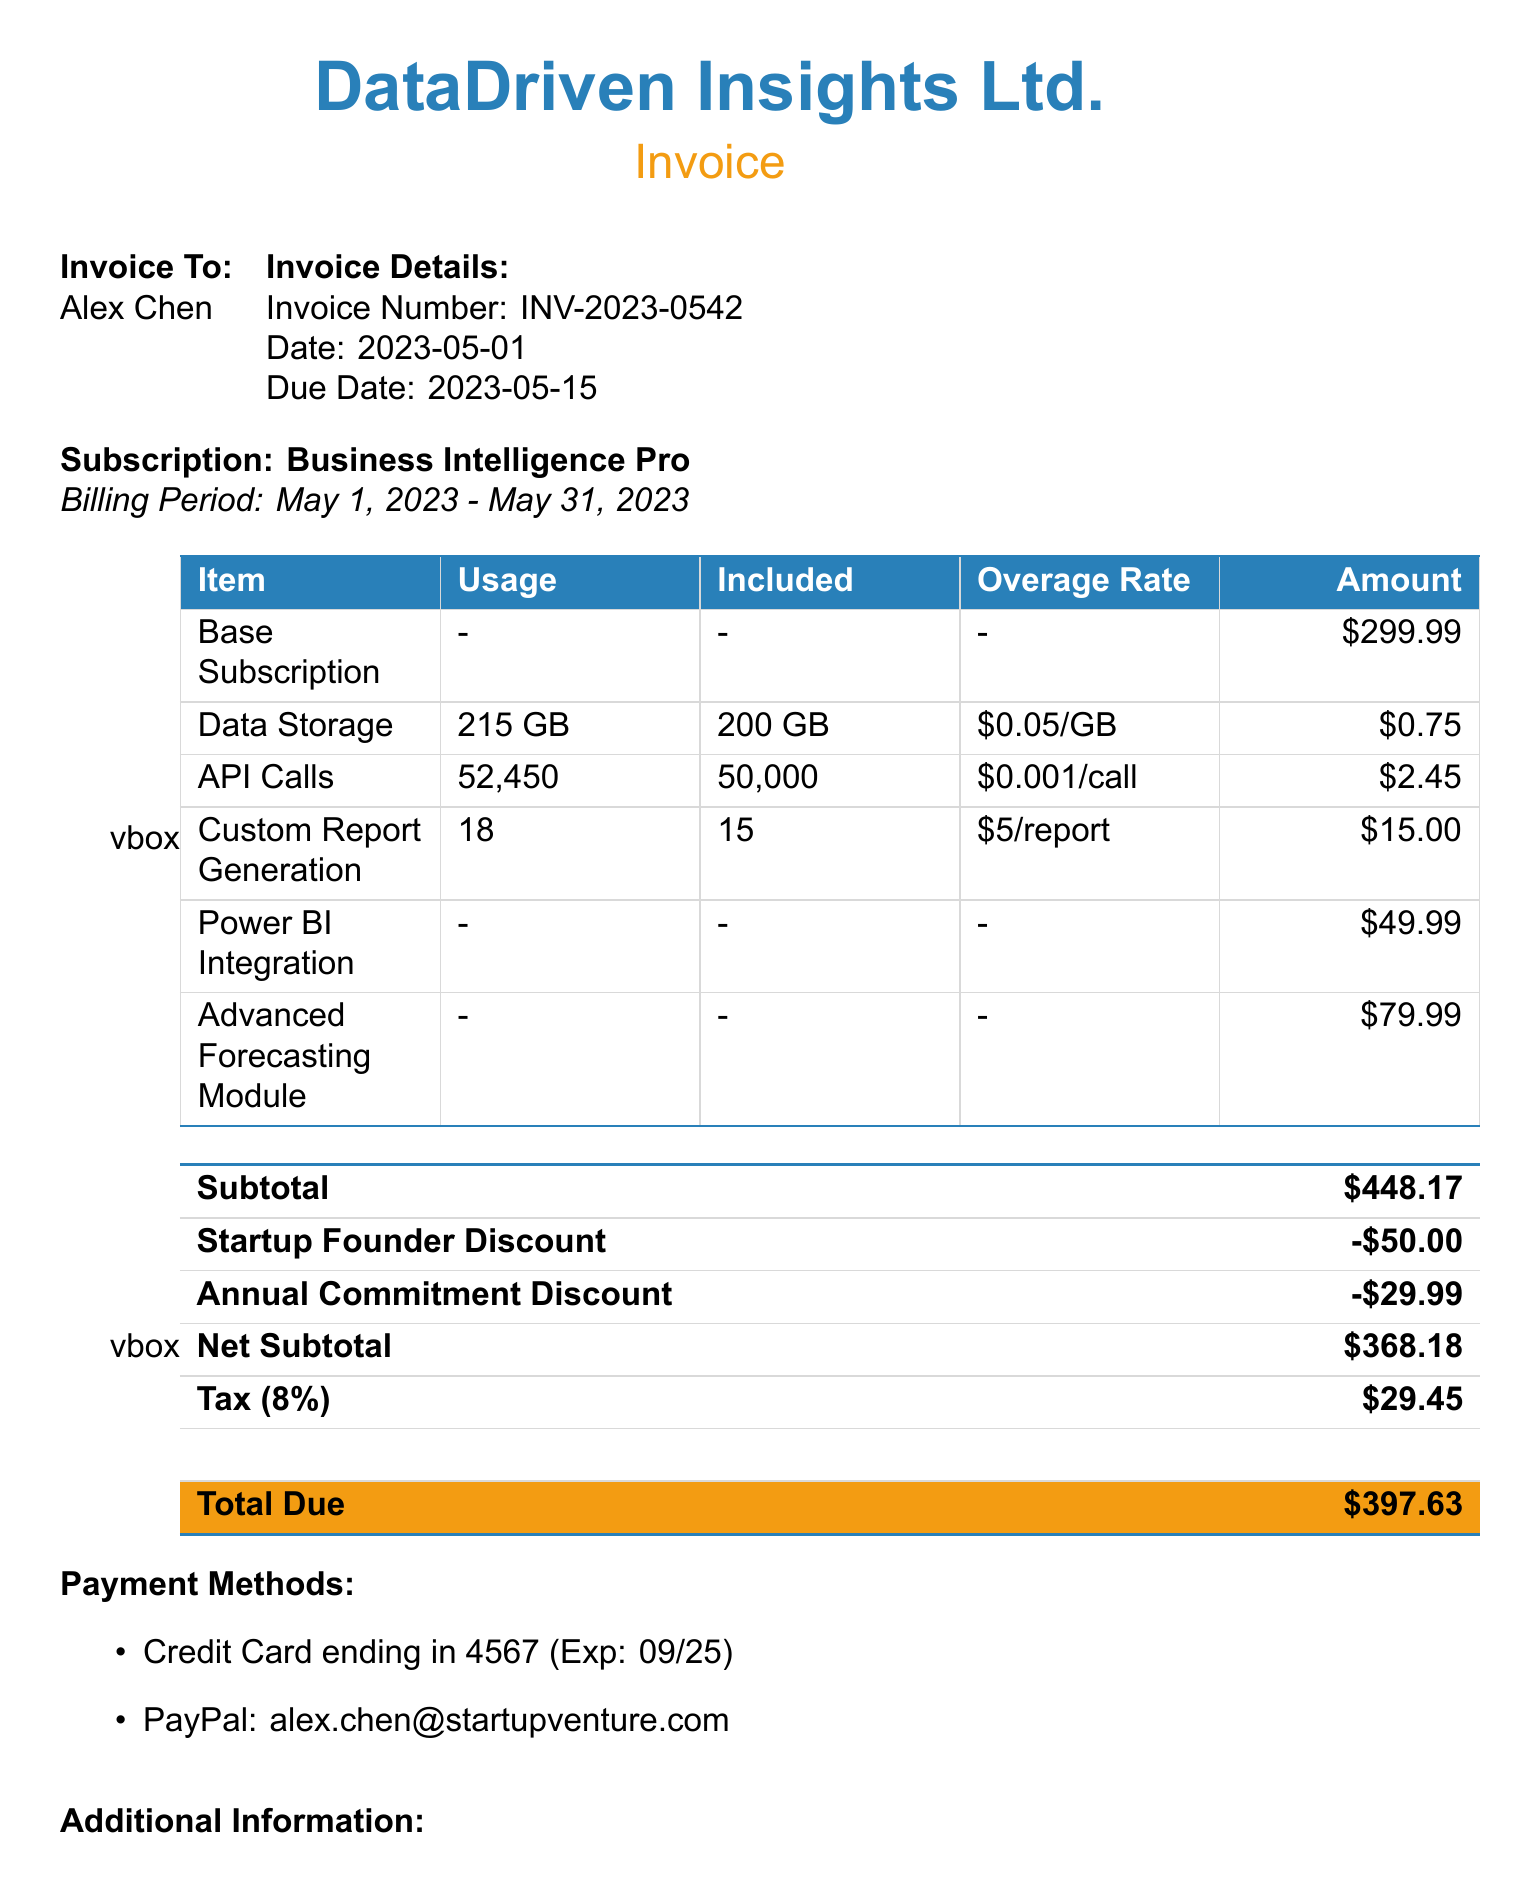What is the customer name? The customer's name is listed in the document as Alex Chen.
Answer: Alex Chen What is the invoice number? The invoice number is specified clearly in the invoice details section.
Answer: INV-2023-0542 What is the billing period for the subscription? The billing period indicates the timeframe for which the service is being billed.
Answer: May 1, 2023 - May 31, 2023 How much is the overage charge for Data Storage? The overage charge for Data Storage is specified next to the usage statistics for that feature.
Answer: $0.75 What is the total due amount? The total amount due is calculated and mentioned at the end of the invoice.
Answer: $397.63 How much is the Startup Founder Discount? The document clearly lists the amount of the Startup Founder Discount under discounts.
Answer: $50.00 What is the tax rate applied? The tax rate is provided alongside the tax amount in the invoice totals section.
Answer: 8% Who is the account manager? The account manager's name is noted in the additional information section of the document.
Answer: Sarah Johnson What features incur overage charges? The features that incur overage charges are listed in the usage statistics section.
Answer: Data Storage, API Calls, Custom Report Generation 